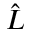Convert formula to latex. <formula><loc_0><loc_0><loc_500><loc_500>\hat { L }</formula> 